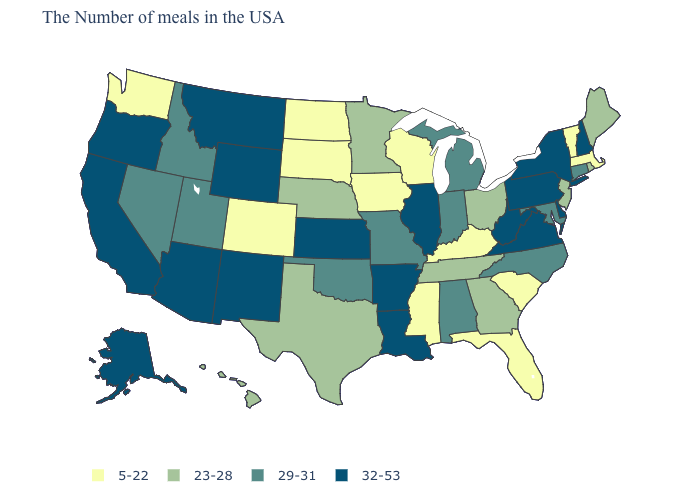What is the value of Nebraska?
Give a very brief answer. 23-28. Among the states that border Mississippi , which have the highest value?
Keep it brief. Louisiana, Arkansas. Which states have the lowest value in the USA?
Short answer required. Massachusetts, Vermont, South Carolina, Florida, Kentucky, Wisconsin, Mississippi, Iowa, South Dakota, North Dakota, Colorado, Washington. Among the states that border Oklahoma , which have the lowest value?
Short answer required. Colorado. Name the states that have a value in the range 29-31?
Be succinct. Connecticut, Maryland, North Carolina, Michigan, Indiana, Alabama, Missouri, Oklahoma, Utah, Idaho, Nevada. Is the legend a continuous bar?
Answer briefly. No. Among the states that border Missouri , does Kentucky have the lowest value?
Keep it brief. Yes. What is the value of Massachusetts?
Short answer required. 5-22. Name the states that have a value in the range 29-31?
Be succinct. Connecticut, Maryland, North Carolina, Michigan, Indiana, Alabama, Missouri, Oklahoma, Utah, Idaho, Nevada. Does Kansas have the highest value in the MidWest?
Short answer required. Yes. Name the states that have a value in the range 23-28?
Write a very short answer. Maine, Rhode Island, New Jersey, Ohio, Georgia, Tennessee, Minnesota, Nebraska, Texas, Hawaii. What is the value of New Hampshire?
Keep it brief. 32-53. Name the states that have a value in the range 23-28?
Answer briefly. Maine, Rhode Island, New Jersey, Ohio, Georgia, Tennessee, Minnesota, Nebraska, Texas, Hawaii. Among the states that border Illinois , does Iowa have the highest value?
Give a very brief answer. No. Name the states that have a value in the range 29-31?
Concise answer only. Connecticut, Maryland, North Carolina, Michigan, Indiana, Alabama, Missouri, Oklahoma, Utah, Idaho, Nevada. 